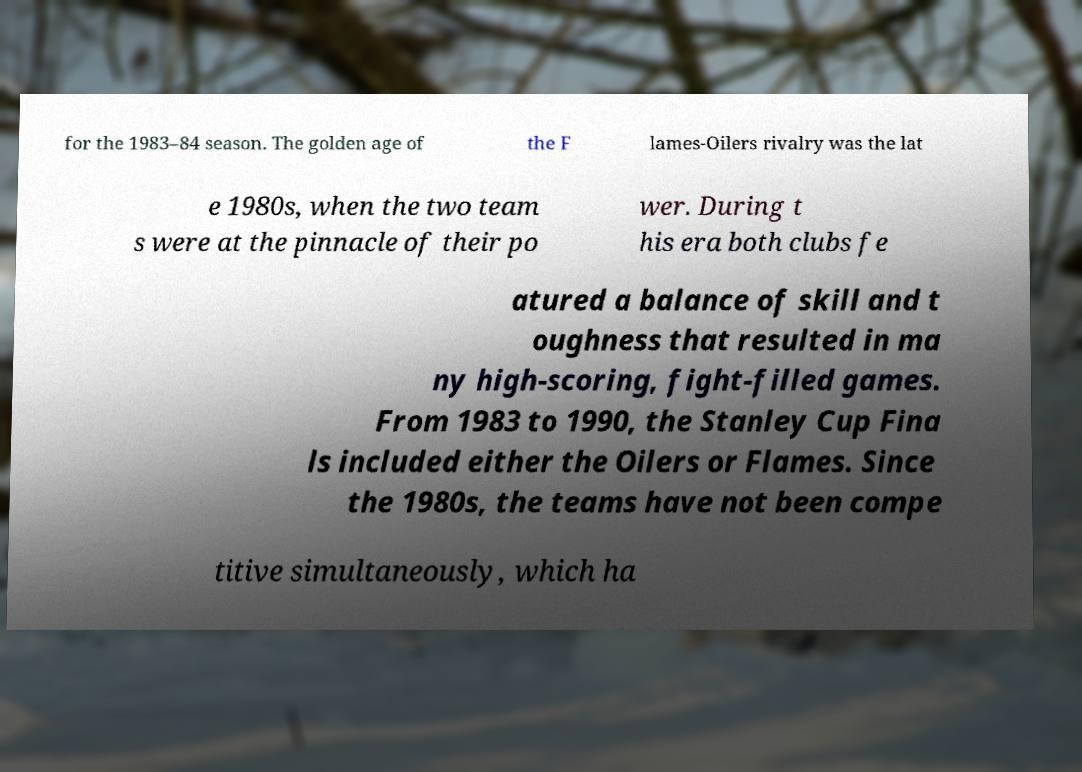Could you extract and type out the text from this image? for the 1983–84 season. The golden age of the F lames-Oilers rivalry was the lat e 1980s, when the two team s were at the pinnacle of their po wer. During t his era both clubs fe atured a balance of skill and t oughness that resulted in ma ny high-scoring, fight-filled games. From 1983 to 1990, the Stanley Cup Fina ls included either the Oilers or Flames. Since the 1980s, the teams have not been compe titive simultaneously, which ha 